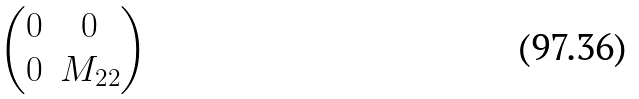<formula> <loc_0><loc_0><loc_500><loc_500>\begin{pmatrix} 0 & 0 \\ 0 & M _ { 2 2 } \\ \end{pmatrix}</formula> 